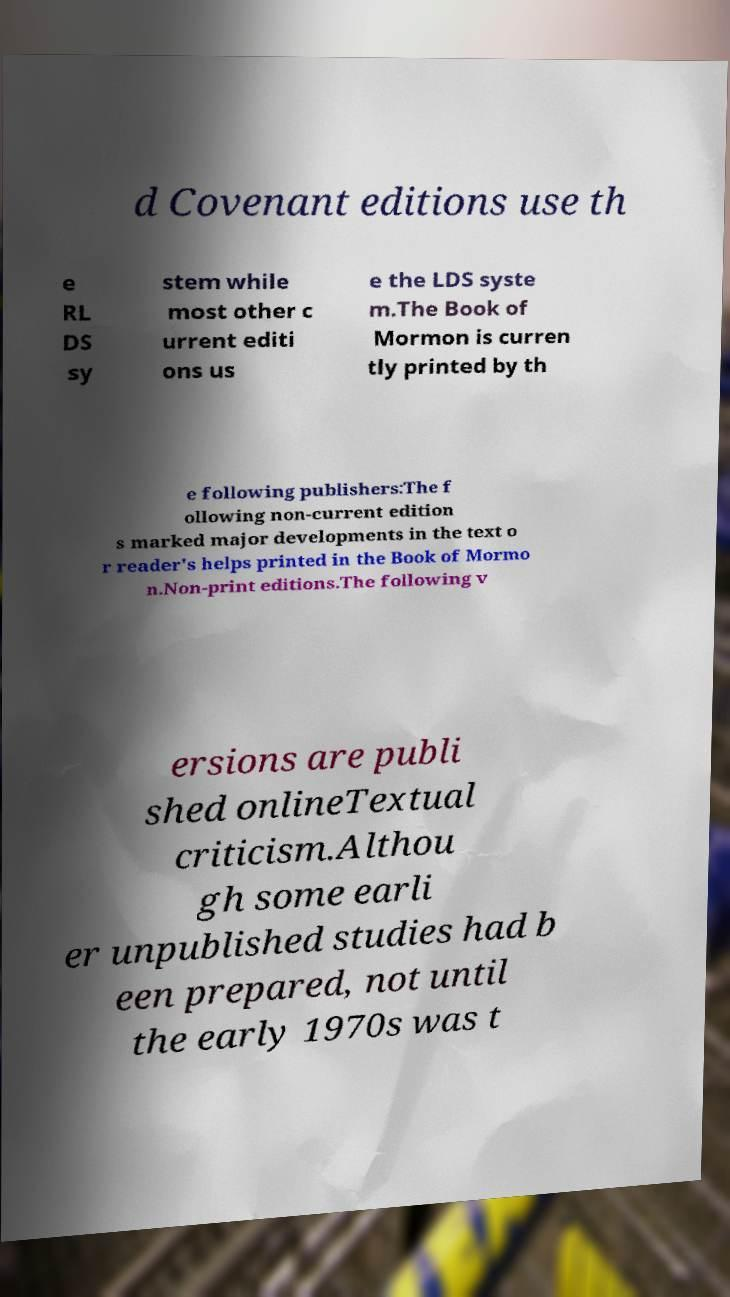Can you accurately transcribe the text from the provided image for me? d Covenant editions use th e RL DS sy stem while most other c urrent editi ons us e the LDS syste m.The Book of Mormon is curren tly printed by th e following publishers:The f ollowing non-current edition s marked major developments in the text o r reader's helps printed in the Book of Mormo n.Non-print editions.The following v ersions are publi shed onlineTextual criticism.Althou gh some earli er unpublished studies had b een prepared, not until the early 1970s was t 